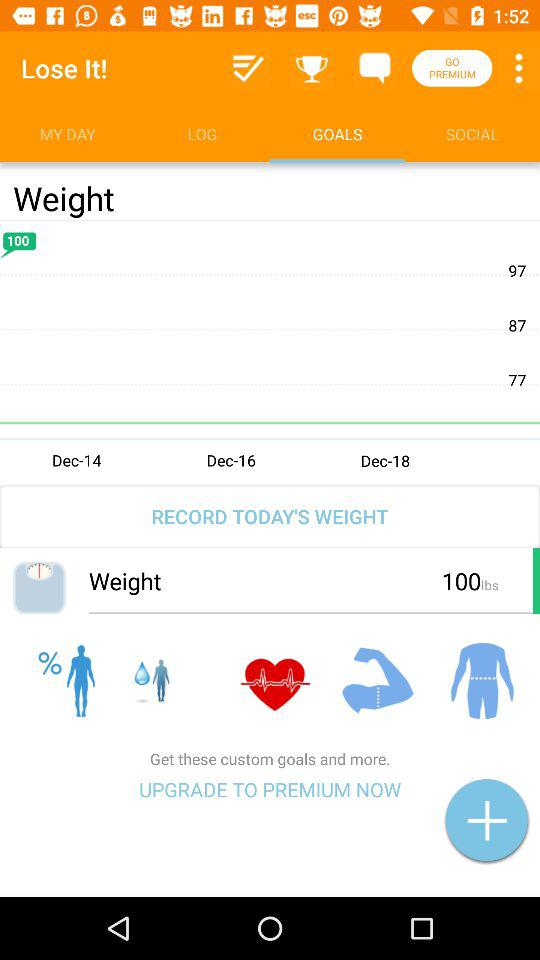What is the application name? The application name is "Lose It!". 